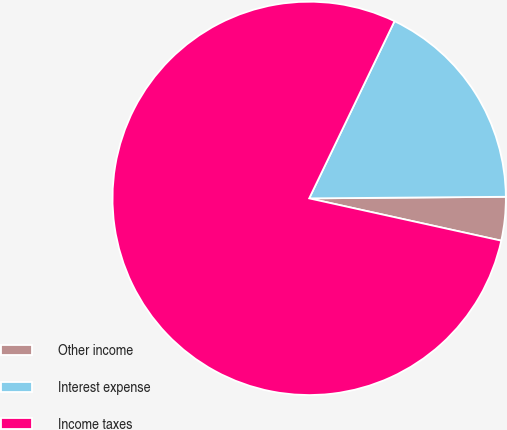<chart> <loc_0><loc_0><loc_500><loc_500><pie_chart><fcel>Other income<fcel>Interest expense<fcel>Income taxes<nl><fcel>3.58%<fcel>17.73%<fcel>78.69%<nl></chart> 